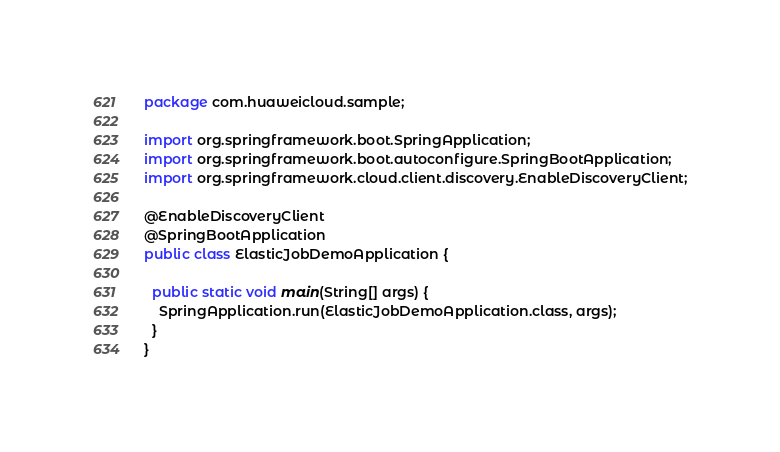<code> <loc_0><loc_0><loc_500><loc_500><_Java_>package com.huaweicloud.sample;

import org.springframework.boot.SpringApplication;
import org.springframework.boot.autoconfigure.SpringBootApplication;
import org.springframework.cloud.client.discovery.EnableDiscoveryClient;

@EnableDiscoveryClient
@SpringBootApplication
public class ElasticJobDemoApplication {

  public static void main(String[] args) {
    SpringApplication.run(ElasticJobDemoApplication.class, args);
  }
}
</code> 